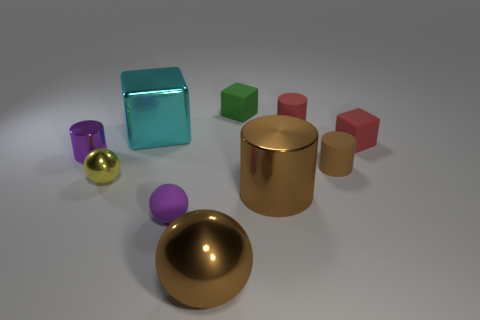Subtract all cubes. How many objects are left? 7 Subtract all green rubber things. Subtract all cyan blocks. How many objects are left? 8 Add 2 purple metallic things. How many purple metallic things are left? 3 Add 4 purple rubber things. How many purple rubber things exist? 5 Subtract 1 red cubes. How many objects are left? 9 